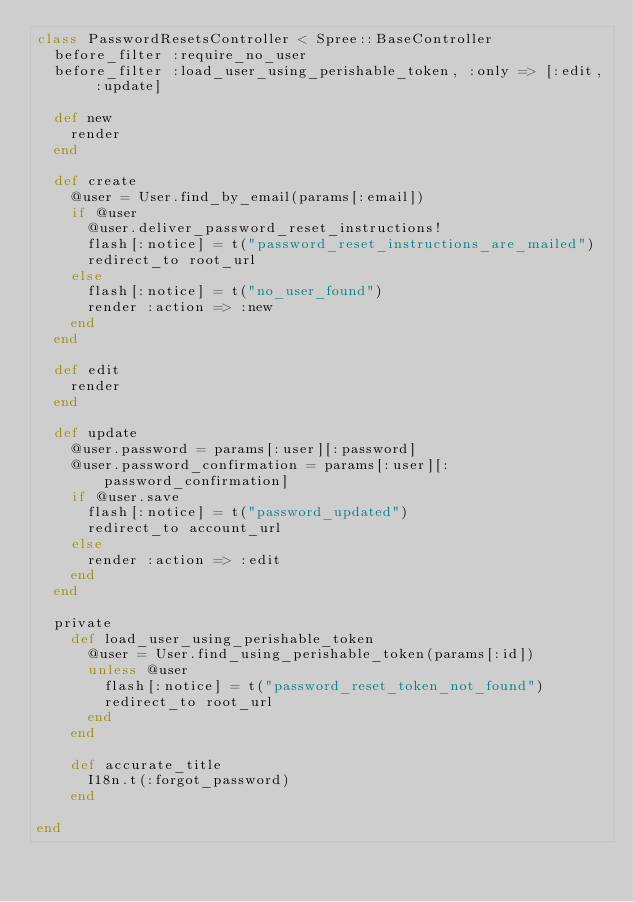<code> <loc_0><loc_0><loc_500><loc_500><_Ruby_>class PasswordResetsController < Spree::BaseController
  before_filter :require_no_user
  before_filter :load_user_using_perishable_token, :only => [:edit, :update]

  def new
    render
  end

  def create
    @user = User.find_by_email(params[:email])
    if @user
      @user.deliver_password_reset_instructions!
      flash[:notice] = t("password_reset_instructions_are_mailed")
      redirect_to root_url
    else
      flash[:notice] = t("no_user_found")
      render :action => :new
    end
  end

  def edit
    render
  end

  def update
    @user.password = params[:user][:password]
    @user.password_confirmation = params[:user][:password_confirmation]
    if @user.save
      flash[:notice] = t("password_updated")
      redirect_to account_url
    else
      render :action => :edit
    end
  end

  private
    def load_user_using_perishable_token
      @user = User.find_using_perishable_token(params[:id])
      unless @user
        flash[:notice] = t("password_reset_token_not_found")
        redirect_to root_url
      end
    end

    def accurate_title
      I18n.t(:forgot_password)
    end

end
</code> 